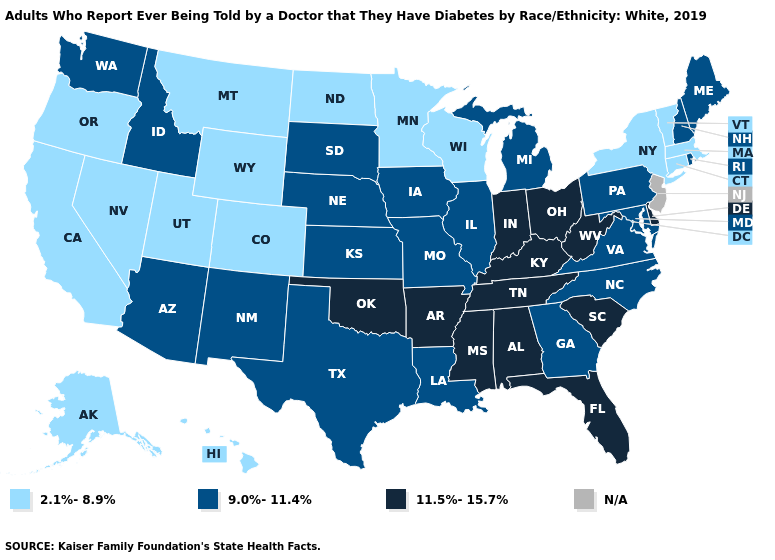Name the states that have a value in the range 11.5%-15.7%?
Concise answer only. Alabama, Arkansas, Delaware, Florida, Indiana, Kentucky, Mississippi, Ohio, Oklahoma, South Carolina, Tennessee, West Virginia. What is the lowest value in the USA?
Give a very brief answer. 2.1%-8.9%. What is the highest value in the USA?
Write a very short answer. 11.5%-15.7%. Name the states that have a value in the range 11.5%-15.7%?
Give a very brief answer. Alabama, Arkansas, Delaware, Florida, Indiana, Kentucky, Mississippi, Ohio, Oklahoma, South Carolina, Tennessee, West Virginia. Does Oklahoma have the highest value in the South?
Keep it brief. Yes. What is the value of Oregon?
Quick response, please. 2.1%-8.9%. Among the states that border Massachusetts , does Rhode Island have the highest value?
Be succinct. Yes. Does Utah have the highest value in the West?
Concise answer only. No. What is the lowest value in the Northeast?
Write a very short answer. 2.1%-8.9%. What is the lowest value in states that border Arizona?
Give a very brief answer. 2.1%-8.9%. Among the states that border Kansas , does Oklahoma have the highest value?
Keep it brief. Yes. What is the highest value in the USA?
Quick response, please. 11.5%-15.7%. 